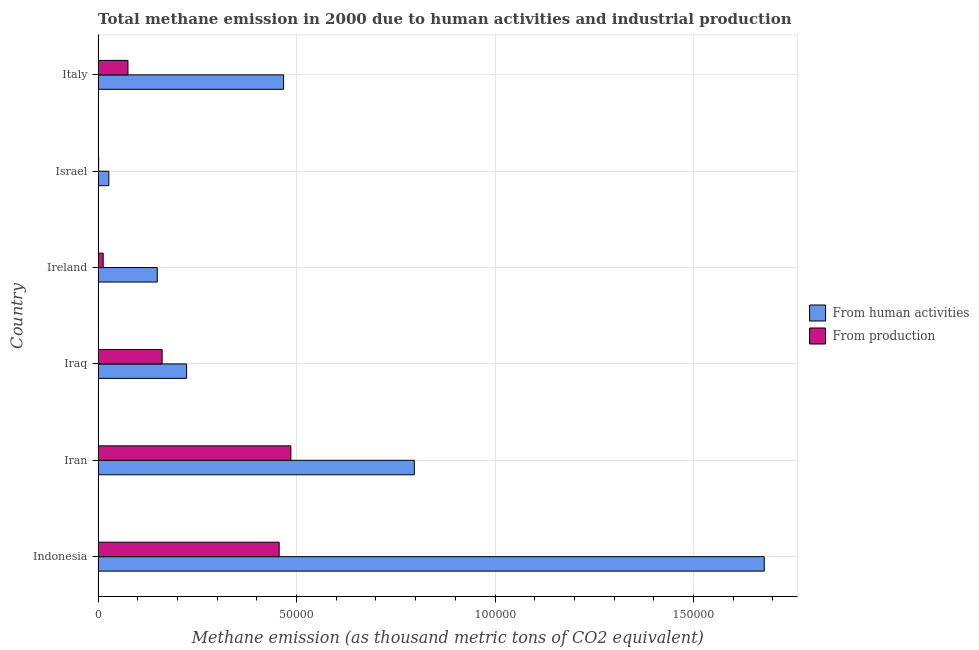How many different coloured bars are there?
Provide a short and direct response. 2. How many groups of bars are there?
Your answer should be very brief. 6. Are the number of bars on each tick of the Y-axis equal?
Your answer should be very brief. Yes. How many bars are there on the 6th tick from the bottom?
Provide a short and direct response. 2. What is the label of the 3rd group of bars from the top?
Ensure brevity in your answer.  Ireland. In how many cases, is the number of bars for a given country not equal to the number of legend labels?
Ensure brevity in your answer.  0. What is the amount of emissions generated from industries in Israel?
Your answer should be compact. 135.8. Across all countries, what is the maximum amount of emissions from human activities?
Offer a very short reply. 1.68e+05. Across all countries, what is the minimum amount of emissions generated from industries?
Your answer should be very brief. 135.8. In which country was the amount of emissions generated from industries maximum?
Provide a short and direct response. Iran. What is the total amount of emissions from human activities in the graph?
Your answer should be compact. 3.34e+05. What is the difference between the amount of emissions generated from industries in Indonesia and that in Iran?
Your answer should be very brief. -2945.6. What is the difference between the amount of emissions from human activities in Israel and the amount of emissions generated from industries in Ireland?
Offer a terse response. 1421.9. What is the average amount of emissions generated from industries per country?
Provide a succinct answer. 1.99e+04. What is the difference between the amount of emissions from human activities and amount of emissions generated from industries in Israel?
Your answer should be very brief. 2563. What is the ratio of the amount of emissions generated from industries in Indonesia to that in Italy?
Offer a terse response. 6.07. Is the difference between the amount of emissions from human activities in Iran and Iraq greater than the difference between the amount of emissions generated from industries in Iran and Iraq?
Offer a terse response. Yes. What is the difference between the highest and the second highest amount of emissions from human activities?
Offer a very short reply. 8.82e+04. What is the difference between the highest and the lowest amount of emissions from human activities?
Ensure brevity in your answer.  1.65e+05. Is the sum of the amount of emissions generated from industries in Iraq and Israel greater than the maximum amount of emissions from human activities across all countries?
Make the answer very short. No. What does the 1st bar from the top in Iran represents?
Ensure brevity in your answer.  From production. What does the 1st bar from the bottom in Israel represents?
Offer a terse response. From human activities. Are all the bars in the graph horizontal?
Make the answer very short. Yes. How many countries are there in the graph?
Provide a succinct answer. 6. What is the difference between two consecutive major ticks on the X-axis?
Provide a succinct answer. 5.00e+04. Does the graph contain grids?
Offer a terse response. Yes. How many legend labels are there?
Offer a terse response. 2. How are the legend labels stacked?
Provide a succinct answer. Vertical. What is the title of the graph?
Ensure brevity in your answer.  Total methane emission in 2000 due to human activities and industrial production. What is the label or title of the X-axis?
Your answer should be very brief. Methane emission (as thousand metric tons of CO2 equivalent). What is the Methane emission (as thousand metric tons of CO2 equivalent) of From human activities in Indonesia?
Offer a very short reply. 1.68e+05. What is the Methane emission (as thousand metric tons of CO2 equivalent) of From production in Indonesia?
Keep it short and to the point. 4.56e+04. What is the Methane emission (as thousand metric tons of CO2 equivalent) of From human activities in Iran?
Keep it short and to the point. 7.97e+04. What is the Methane emission (as thousand metric tons of CO2 equivalent) of From production in Iran?
Offer a terse response. 4.86e+04. What is the Methane emission (as thousand metric tons of CO2 equivalent) of From human activities in Iraq?
Offer a very short reply. 2.23e+04. What is the Methane emission (as thousand metric tons of CO2 equivalent) in From production in Iraq?
Provide a short and direct response. 1.61e+04. What is the Methane emission (as thousand metric tons of CO2 equivalent) in From human activities in Ireland?
Ensure brevity in your answer.  1.49e+04. What is the Methane emission (as thousand metric tons of CO2 equivalent) of From production in Ireland?
Provide a short and direct response. 1276.9. What is the Methane emission (as thousand metric tons of CO2 equivalent) of From human activities in Israel?
Your answer should be very brief. 2698.8. What is the Methane emission (as thousand metric tons of CO2 equivalent) of From production in Israel?
Provide a short and direct response. 135.8. What is the Methane emission (as thousand metric tons of CO2 equivalent) in From human activities in Italy?
Provide a short and direct response. 4.67e+04. What is the Methane emission (as thousand metric tons of CO2 equivalent) in From production in Italy?
Provide a short and direct response. 7519.2. Across all countries, what is the maximum Methane emission (as thousand metric tons of CO2 equivalent) of From human activities?
Ensure brevity in your answer.  1.68e+05. Across all countries, what is the maximum Methane emission (as thousand metric tons of CO2 equivalent) in From production?
Your answer should be very brief. 4.86e+04. Across all countries, what is the minimum Methane emission (as thousand metric tons of CO2 equivalent) in From human activities?
Offer a terse response. 2698.8. Across all countries, what is the minimum Methane emission (as thousand metric tons of CO2 equivalent) of From production?
Ensure brevity in your answer.  135.8. What is the total Methane emission (as thousand metric tons of CO2 equivalent) of From human activities in the graph?
Keep it short and to the point. 3.34e+05. What is the total Methane emission (as thousand metric tons of CO2 equivalent) in From production in the graph?
Your answer should be very brief. 1.19e+05. What is the difference between the Methane emission (as thousand metric tons of CO2 equivalent) of From human activities in Indonesia and that in Iran?
Provide a succinct answer. 8.82e+04. What is the difference between the Methane emission (as thousand metric tons of CO2 equivalent) of From production in Indonesia and that in Iran?
Provide a succinct answer. -2945.6. What is the difference between the Methane emission (as thousand metric tons of CO2 equivalent) of From human activities in Indonesia and that in Iraq?
Your answer should be very brief. 1.46e+05. What is the difference between the Methane emission (as thousand metric tons of CO2 equivalent) of From production in Indonesia and that in Iraq?
Make the answer very short. 2.95e+04. What is the difference between the Methane emission (as thousand metric tons of CO2 equivalent) of From human activities in Indonesia and that in Ireland?
Your answer should be very brief. 1.53e+05. What is the difference between the Methane emission (as thousand metric tons of CO2 equivalent) of From production in Indonesia and that in Ireland?
Your answer should be compact. 4.43e+04. What is the difference between the Methane emission (as thousand metric tons of CO2 equivalent) of From human activities in Indonesia and that in Israel?
Your answer should be very brief. 1.65e+05. What is the difference between the Methane emission (as thousand metric tons of CO2 equivalent) of From production in Indonesia and that in Israel?
Your answer should be compact. 4.55e+04. What is the difference between the Methane emission (as thousand metric tons of CO2 equivalent) of From human activities in Indonesia and that in Italy?
Offer a terse response. 1.21e+05. What is the difference between the Methane emission (as thousand metric tons of CO2 equivalent) of From production in Indonesia and that in Italy?
Provide a succinct answer. 3.81e+04. What is the difference between the Methane emission (as thousand metric tons of CO2 equivalent) in From human activities in Iran and that in Iraq?
Ensure brevity in your answer.  5.74e+04. What is the difference between the Methane emission (as thousand metric tons of CO2 equivalent) of From production in Iran and that in Iraq?
Make the answer very short. 3.24e+04. What is the difference between the Methane emission (as thousand metric tons of CO2 equivalent) of From human activities in Iran and that in Ireland?
Offer a terse response. 6.48e+04. What is the difference between the Methane emission (as thousand metric tons of CO2 equivalent) in From production in Iran and that in Ireland?
Your answer should be very brief. 4.73e+04. What is the difference between the Methane emission (as thousand metric tons of CO2 equivalent) of From human activities in Iran and that in Israel?
Your answer should be very brief. 7.70e+04. What is the difference between the Methane emission (as thousand metric tons of CO2 equivalent) of From production in Iran and that in Israel?
Your response must be concise. 4.84e+04. What is the difference between the Methane emission (as thousand metric tons of CO2 equivalent) in From human activities in Iran and that in Italy?
Your response must be concise. 3.29e+04. What is the difference between the Methane emission (as thousand metric tons of CO2 equivalent) in From production in Iran and that in Italy?
Your answer should be compact. 4.10e+04. What is the difference between the Methane emission (as thousand metric tons of CO2 equivalent) of From human activities in Iraq and that in Ireland?
Keep it short and to the point. 7392. What is the difference between the Methane emission (as thousand metric tons of CO2 equivalent) in From production in Iraq and that in Ireland?
Ensure brevity in your answer.  1.48e+04. What is the difference between the Methane emission (as thousand metric tons of CO2 equivalent) in From human activities in Iraq and that in Israel?
Offer a terse response. 1.96e+04. What is the difference between the Methane emission (as thousand metric tons of CO2 equivalent) of From production in Iraq and that in Israel?
Give a very brief answer. 1.60e+04. What is the difference between the Methane emission (as thousand metric tons of CO2 equivalent) of From human activities in Iraq and that in Italy?
Offer a terse response. -2.44e+04. What is the difference between the Methane emission (as thousand metric tons of CO2 equivalent) in From production in Iraq and that in Italy?
Provide a succinct answer. 8606.5. What is the difference between the Methane emission (as thousand metric tons of CO2 equivalent) of From human activities in Ireland and that in Israel?
Ensure brevity in your answer.  1.22e+04. What is the difference between the Methane emission (as thousand metric tons of CO2 equivalent) in From production in Ireland and that in Israel?
Provide a succinct answer. 1141.1. What is the difference between the Methane emission (as thousand metric tons of CO2 equivalent) of From human activities in Ireland and that in Italy?
Offer a terse response. -3.18e+04. What is the difference between the Methane emission (as thousand metric tons of CO2 equivalent) of From production in Ireland and that in Italy?
Offer a very short reply. -6242.3. What is the difference between the Methane emission (as thousand metric tons of CO2 equivalent) in From human activities in Israel and that in Italy?
Provide a short and direct response. -4.40e+04. What is the difference between the Methane emission (as thousand metric tons of CO2 equivalent) in From production in Israel and that in Italy?
Offer a very short reply. -7383.4. What is the difference between the Methane emission (as thousand metric tons of CO2 equivalent) in From human activities in Indonesia and the Methane emission (as thousand metric tons of CO2 equivalent) in From production in Iran?
Keep it short and to the point. 1.19e+05. What is the difference between the Methane emission (as thousand metric tons of CO2 equivalent) in From human activities in Indonesia and the Methane emission (as thousand metric tons of CO2 equivalent) in From production in Iraq?
Give a very brief answer. 1.52e+05. What is the difference between the Methane emission (as thousand metric tons of CO2 equivalent) of From human activities in Indonesia and the Methane emission (as thousand metric tons of CO2 equivalent) of From production in Ireland?
Keep it short and to the point. 1.67e+05. What is the difference between the Methane emission (as thousand metric tons of CO2 equivalent) in From human activities in Indonesia and the Methane emission (as thousand metric tons of CO2 equivalent) in From production in Israel?
Your response must be concise. 1.68e+05. What is the difference between the Methane emission (as thousand metric tons of CO2 equivalent) in From human activities in Indonesia and the Methane emission (as thousand metric tons of CO2 equivalent) in From production in Italy?
Provide a succinct answer. 1.60e+05. What is the difference between the Methane emission (as thousand metric tons of CO2 equivalent) in From human activities in Iran and the Methane emission (as thousand metric tons of CO2 equivalent) in From production in Iraq?
Give a very brief answer. 6.35e+04. What is the difference between the Methane emission (as thousand metric tons of CO2 equivalent) in From human activities in Iran and the Methane emission (as thousand metric tons of CO2 equivalent) in From production in Ireland?
Provide a short and direct response. 7.84e+04. What is the difference between the Methane emission (as thousand metric tons of CO2 equivalent) of From human activities in Iran and the Methane emission (as thousand metric tons of CO2 equivalent) of From production in Israel?
Offer a very short reply. 7.95e+04. What is the difference between the Methane emission (as thousand metric tons of CO2 equivalent) of From human activities in Iran and the Methane emission (as thousand metric tons of CO2 equivalent) of From production in Italy?
Your answer should be compact. 7.21e+04. What is the difference between the Methane emission (as thousand metric tons of CO2 equivalent) in From human activities in Iraq and the Methane emission (as thousand metric tons of CO2 equivalent) in From production in Ireland?
Your answer should be compact. 2.10e+04. What is the difference between the Methane emission (as thousand metric tons of CO2 equivalent) of From human activities in Iraq and the Methane emission (as thousand metric tons of CO2 equivalent) of From production in Israel?
Your answer should be very brief. 2.22e+04. What is the difference between the Methane emission (as thousand metric tons of CO2 equivalent) in From human activities in Iraq and the Methane emission (as thousand metric tons of CO2 equivalent) in From production in Italy?
Offer a very short reply. 1.48e+04. What is the difference between the Methane emission (as thousand metric tons of CO2 equivalent) of From human activities in Ireland and the Methane emission (as thousand metric tons of CO2 equivalent) of From production in Israel?
Provide a short and direct response. 1.48e+04. What is the difference between the Methane emission (as thousand metric tons of CO2 equivalent) in From human activities in Ireland and the Methane emission (as thousand metric tons of CO2 equivalent) in From production in Italy?
Ensure brevity in your answer.  7377.8. What is the difference between the Methane emission (as thousand metric tons of CO2 equivalent) in From human activities in Israel and the Methane emission (as thousand metric tons of CO2 equivalent) in From production in Italy?
Offer a terse response. -4820.4. What is the average Methane emission (as thousand metric tons of CO2 equivalent) in From human activities per country?
Ensure brevity in your answer.  5.57e+04. What is the average Methane emission (as thousand metric tons of CO2 equivalent) in From production per country?
Provide a succinct answer. 1.99e+04. What is the difference between the Methane emission (as thousand metric tons of CO2 equivalent) in From human activities and Methane emission (as thousand metric tons of CO2 equivalent) in From production in Indonesia?
Your answer should be very brief. 1.22e+05. What is the difference between the Methane emission (as thousand metric tons of CO2 equivalent) of From human activities and Methane emission (as thousand metric tons of CO2 equivalent) of From production in Iran?
Give a very brief answer. 3.11e+04. What is the difference between the Methane emission (as thousand metric tons of CO2 equivalent) of From human activities and Methane emission (as thousand metric tons of CO2 equivalent) of From production in Iraq?
Provide a short and direct response. 6163.3. What is the difference between the Methane emission (as thousand metric tons of CO2 equivalent) in From human activities and Methane emission (as thousand metric tons of CO2 equivalent) in From production in Ireland?
Give a very brief answer. 1.36e+04. What is the difference between the Methane emission (as thousand metric tons of CO2 equivalent) of From human activities and Methane emission (as thousand metric tons of CO2 equivalent) of From production in Israel?
Your answer should be very brief. 2563. What is the difference between the Methane emission (as thousand metric tons of CO2 equivalent) of From human activities and Methane emission (as thousand metric tons of CO2 equivalent) of From production in Italy?
Make the answer very short. 3.92e+04. What is the ratio of the Methane emission (as thousand metric tons of CO2 equivalent) of From human activities in Indonesia to that in Iran?
Offer a terse response. 2.11. What is the ratio of the Methane emission (as thousand metric tons of CO2 equivalent) in From production in Indonesia to that in Iran?
Your answer should be very brief. 0.94. What is the ratio of the Methane emission (as thousand metric tons of CO2 equivalent) in From human activities in Indonesia to that in Iraq?
Your answer should be very brief. 7.53. What is the ratio of the Methane emission (as thousand metric tons of CO2 equivalent) in From production in Indonesia to that in Iraq?
Offer a very short reply. 2.83. What is the ratio of the Methane emission (as thousand metric tons of CO2 equivalent) of From human activities in Indonesia to that in Ireland?
Provide a short and direct response. 11.27. What is the ratio of the Methane emission (as thousand metric tons of CO2 equivalent) of From production in Indonesia to that in Ireland?
Offer a very short reply. 35.72. What is the ratio of the Methane emission (as thousand metric tons of CO2 equivalent) in From human activities in Indonesia to that in Israel?
Make the answer very short. 62.18. What is the ratio of the Methane emission (as thousand metric tons of CO2 equivalent) in From production in Indonesia to that in Israel?
Make the answer very short. 335.89. What is the ratio of the Methane emission (as thousand metric tons of CO2 equivalent) in From human activities in Indonesia to that in Italy?
Make the answer very short. 3.59. What is the ratio of the Methane emission (as thousand metric tons of CO2 equivalent) of From production in Indonesia to that in Italy?
Give a very brief answer. 6.07. What is the ratio of the Methane emission (as thousand metric tons of CO2 equivalent) in From human activities in Iran to that in Iraq?
Give a very brief answer. 3.57. What is the ratio of the Methane emission (as thousand metric tons of CO2 equivalent) of From production in Iran to that in Iraq?
Make the answer very short. 3.01. What is the ratio of the Methane emission (as thousand metric tons of CO2 equivalent) of From human activities in Iran to that in Ireland?
Your answer should be very brief. 5.35. What is the ratio of the Methane emission (as thousand metric tons of CO2 equivalent) in From production in Iran to that in Ireland?
Offer a terse response. 38.03. What is the ratio of the Methane emission (as thousand metric tons of CO2 equivalent) of From human activities in Iran to that in Israel?
Provide a succinct answer. 29.52. What is the ratio of the Methane emission (as thousand metric tons of CO2 equivalent) in From production in Iran to that in Israel?
Your answer should be very brief. 357.58. What is the ratio of the Methane emission (as thousand metric tons of CO2 equivalent) of From human activities in Iran to that in Italy?
Make the answer very short. 1.71. What is the ratio of the Methane emission (as thousand metric tons of CO2 equivalent) of From production in Iran to that in Italy?
Provide a succinct answer. 6.46. What is the ratio of the Methane emission (as thousand metric tons of CO2 equivalent) of From human activities in Iraq to that in Ireland?
Provide a succinct answer. 1.5. What is the ratio of the Methane emission (as thousand metric tons of CO2 equivalent) in From production in Iraq to that in Ireland?
Keep it short and to the point. 12.63. What is the ratio of the Methane emission (as thousand metric tons of CO2 equivalent) in From human activities in Iraq to that in Israel?
Keep it short and to the point. 8.26. What is the ratio of the Methane emission (as thousand metric tons of CO2 equivalent) in From production in Iraq to that in Israel?
Provide a succinct answer. 118.75. What is the ratio of the Methane emission (as thousand metric tons of CO2 equivalent) in From human activities in Iraq to that in Italy?
Your answer should be compact. 0.48. What is the ratio of the Methane emission (as thousand metric tons of CO2 equivalent) of From production in Iraq to that in Italy?
Ensure brevity in your answer.  2.14. What is the ratio of the Methane emission (as thousand metric tons of CO2 equivalent) in From human activities in Ireland to that in Israel?
Ensure brevity in your answer.  5.52. What is the ratio of the Methane emission (as thousand metric tons of CO2 equivalent) in From production in Ireland to that in Israel?
Your answer should be compact. 9.4. What is the ratio of the Methane emission (as thousand metric tons of CO2 equivalent) in From human activities in Ireland to that in Italy?
Your answer should be compact. 0.32. What is the ratio of the Methane emission (as thousand metric tons of CO2 equivalent) in From production in Ireland to that in Italy?
Provide a short and direct response. 0.17. What is the ratio of the Methane emission (as thousand metric tons of CO2 equivalent) in From human activities in Israel to that in Italy?
Offer a terse response. 0.06. What is the ratio of the Methane emission (as thousand metric tons of CO2 equivalent) in From production in Israel to that in Italy?
Provide a short and direct response. 0.02. What is the difference between the highest and the second highest Methane emission (as thousand metric tons of CO2 equivalent) of From human activities?
Provide a succinct answer. 8.82e+04. What is the difference between the highest and the second highest Methane emission (as thousand metric tons of CO2 equivalent) of From production?
Offer a very short reply. 2945.6. What is the difference between the highest and the lowest Methane emission (as thousand metric tons of CO2 equivalent) of From human activities?
Your response must be concise. 1.65e+05. What is the difference between the highest and the lowest Methane emission (as thousand metric tons of CO2 equivalent) of From production?
Make the answer very short. 4.84e+04. 